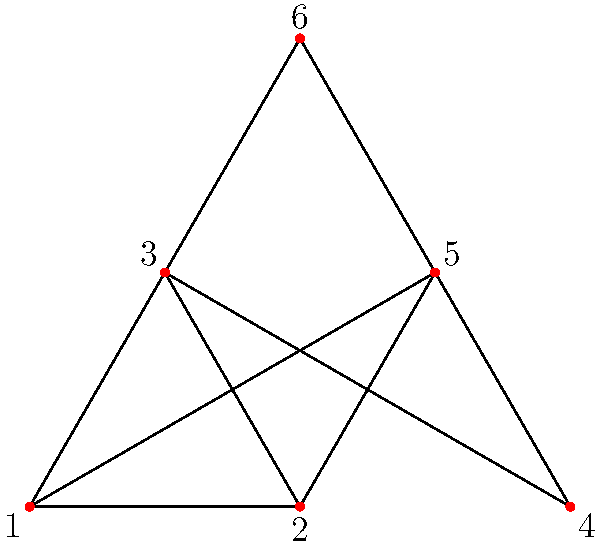As a committee member organizing a graph theory symposium, you're reviewing a presentation on chromatic numbers. The speaker claims that determining the chromatic number of a planar graph is NP-hard in general, but for specific classes of planar graphs, it can be easier. They present the above graph as an example. What is the chromatic number of this planar graph, and how might this relate to the Four Color Theorem? To determine the chromatic number of this planar graph, we can follow these steps:

1. Recall that the Four Color Theorem states that any planar graph can be colored using at most four colors, such that no adjacent vertices share the same color.

2. Observe that the graph contains a complete subgraph (clique) of size 3, formed by vertices 1, 2, and 3. This means we need at least 3 colors.

3. Try to color the graph with 3 colors:
   - Assign color 1 to vertex 1
   - Assign color 2 to vertex 2
   - Assign color 3 to vertex 3
   - Vertex 4 can be colored with color 1
   - Vertex 5 can be colored with color 3
   - Vertex 6 can be colored with color 2

4. We have successfully colored the graph using 3 colors, and no adjacent vertices share the same color.

5. Therefore, the chromatic number of this graph is 3.

This example relates to the Four Color Theorem by demonstrating that while four colors are sufficient for any planar graph, some planar graphs can be colored with fewer colors. In this case, three colors are both necessary and sufficient.

The example illustrates that for specific classes of planar graphs (like this one), determining the chromatic number can be straightforward, even though the general problem for arbitrary planar graphs is more complex.
Answer: 3 